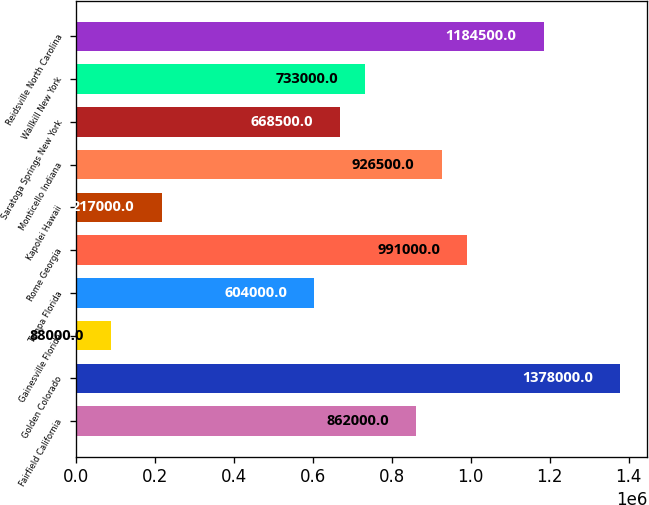<chart> <loc_0><loc_0><loc_500><loc_500><bar_chart><fcel>Fairfield California<fcel>Golden Colorado<fcel>Gainesville Florida<fcel>Tampa Florida<fcel>Rome Georgia<fcel>Kapolei Hawaii<fcel>Monticello Indiana<fcel>Saratoga Springs New York<fcel>Wallkill New York<fcel>Reidsville North Carolina<nl><fcel>862000<fcel>1.378e+06<fcel>88000<fcel>604000<fcel>991000<fcel>217000<fcel>926500<fcel>668500<fcel>733000<fcel>1.1845e+06<nl></chart> 